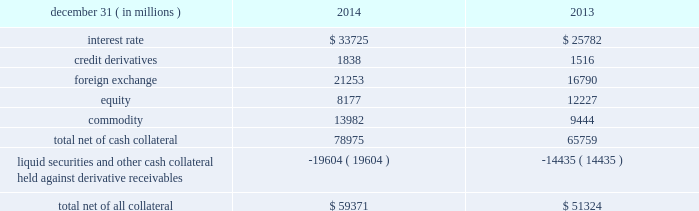Jpmorgan chase & co./2014 annual report 125 lending-related commitments the firm uses lending-related financial instruments , such as commitments ( including revolving credit facilities ) and guarantees , to meet the financing needs of its customers .
The contractual amounts of these financial instruments represent the maximum possible credit risk should the counterparties draw down on these commitments or the firm fulfills its obligations under these guarantees , and the counterparties subsequently fail to perform according to the terms of these contracts .
In the firm 2019s view , the total contractual amount of these wholesale lending-related commitments is not representative of the firm 2019s actual future credit exposure or funding requirements .
In determining the amount of credit risk exposure the firm has to wholesale lending-related commitments , which is used as the basis for allocating credit risk capital to these commitments , the firm has established a 201cloan-equivalent 201d amount for each commitment ; this amount represents the portion of the unused commitment or other contingent exposure that is expected , based on average portfolio historical experience , to become drawn upon in an event of a default by an obligor .
The loan-equivalent amount of the firm 2019s lending- related commitments was $ 229.6 billion and $ 218.9 billion as of december 31 , 2014 and 2013 , respectively .
Clearing services the firm provides clearing services for clients entering into securities and derivative transactions .
Through the provision of these services the firm is exposed to the risk of non-performance by its clients and may be required to share in losses incurred by central counterparties ( 201cccps 201d ) .
Where possible , the firm seeks to mitigate its credit risk to its clients through the collection of adequate margin at inception and throughout the life of the transactions and can also cease provision of clearing services if clients do not adhere to their obligations under the clearing agreement .
For further discussion of clearing services , see note 29 .
Derivative contracts in the normal course of business , the firm uses derivative instruments predominantly for market-making activities .
Derivatives enable customers to manage exposures to fluctuations in interest rates , currencies and other markets .
The firm also uses derivative instruments to manage its own credit exposure .
The nature of the counterparty and the settlement mechanism of the derivative affect the credit risk to which the firm is exposed .
For otc derivatives the firm is exposed to the credit risk of the derivative counterparty .
For exchange-traded derivatives ( 201cetd 201d ) such as futures and options , and 201ccleared 201d over-the-counter ( 201cotc-cleared 201d ) derivatives , the firm is generally exposed to the credit risk of the relevant ccp .
Where possible , the firm seeks to mitigate its credit risk exposures arising from derivative transactions through the use of legally enforceable master netting arrangements and collateral agreements .
For further discussion of derivative contracts , counterparties and settlement types , see note 6 .
The table summarizes the net derivative receivables for the periods presented .
Derivative receivables .
Derivative receivables reported on the consolidated balance sheets were $ 79.0 billion and $ 65.8 billion at december 31 , 2014 and 2013 , respectively .
These amounts represent the fair value of the derivative contracts , after giving effect to legally enforceable master netting agreements and cash collateral held by the firm .
However , in management 2019s view , the appropriate measure of current credit risk should also take into consideration additional liquid securities ( primarily u.s .
Government and agency securities and other g7 government bonds ) and other cash collateral held by the firm aggregating $ 19.6 billion and $ 14.4 billion at december 31 , 2014 and 2013 , respectively , that may be used as security when the fair value of the client 2019s exposure is in the firm 2019s favor .
In addition to the collateral described in the preceding paragraph , the firm also holds additional collateral ( primarily : cash ; g7 government securities ; other liquid government-agency and guaranteed securities ; and corporate debt and equity securities ) delivered by clients at the initiation of transactions , as well as collateral related to contracts that have a non-daily call frequency and collateral that the firm has agreed to return but has not yet settled as of the reporting date .
Although this collateral does not reduce the balances and is not included in the table above , it is available as security against potential exposure that could arise should the fair value of the client 2019s derivative transactions move in the firm 2019s favor .
As of december 31 , 2014 and 2013 , the firm held $ 48.6 billion and $ 50.8 billion , respectively , of this additional collateral .
The prior period amount has been revised to conform with the current period presentation .
The derivative receivables fair value , net of all collateral , also does not include other credit enhancements , such as letters of credit .
For additional information on the firm 2019s use of collateral agreements , see note 6. .
What was the ratio of the derivative receivables reported on the consolidated balance sheets for 2014 to 2013? 
Computations: (79.0 / 65.8)
Answer: 1.20061. 